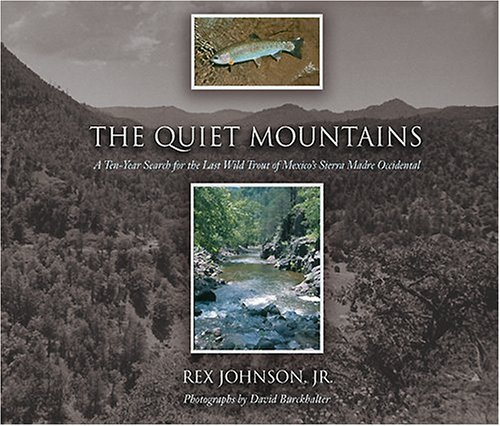What is the title of this book? The book's title is 'The Quiet Mountains: A Ten-Year Search for the Last Wild Trout of Mexico's Sierra Madre Occidental'. 